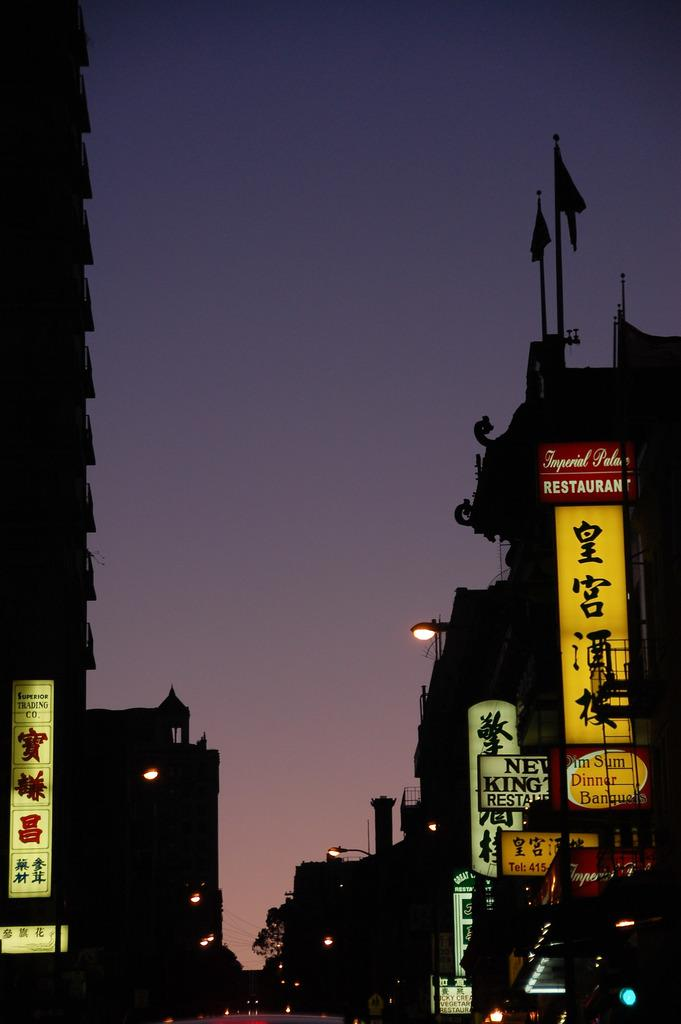<image>
Share a concise interpretation of the image provided. Imperial Palace restaurant is on the right and they serve dim sum. 